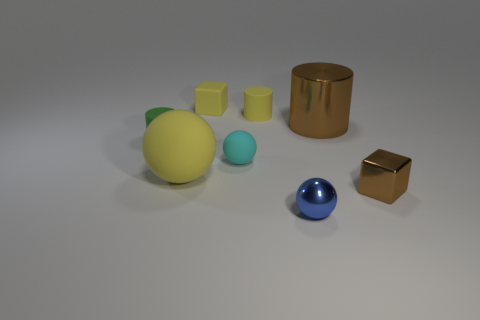Subtract all tiny yellow cylinders. How many cylinders are left? 2 Subtract 1 spheres. How many spheres are left? 2 Subtract all yellow spheres. How many spheres are left? 2 Subtract all cyan rubber things. Subtract all large metal cylinders. How many objects are left? 6 Add 6 metal cylinders. How many metal cylinders are left? 7 Add 6 small cyan matte objects. How many small cyan matte objects exist? 7 Add 2 blue shiny objects. How many objects exist? 10 Subtract 1 blue spheres. How many objects are left? 7 Subtract all cubes. How many objects are left? 6 Subtract all blue balls. Subtract all gray cubes. How many balls are left? 2 